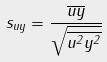Convert formula to latex. <formula><loc_0><loc_0><loc_500><loc_500>s _ { u y } = \frac { \overline { u y } } { \sqrt { \overline { u ^ { 2 } } \overline { y ^ { 2 } } } }</formula> 